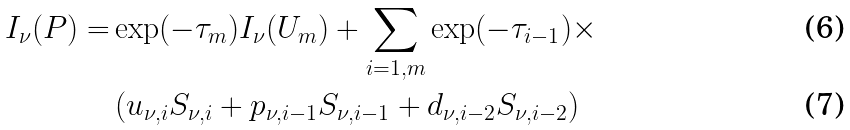<formula> <loc_0><loc_0><loc_500><loc_500>I _ { \nu } ( P ) = & \exp ( - \tau _ { m } ) I _ { \nu } ( U _ { m } ) + \sum _ { i = 1 , m } \exp ( - \tau _ { i - 1 } ) \times \\ & \left ( u _ { \nu , i } S _ { \nu , i } + p _ { \nu , i - 1 } S _ { \nu , i - 1 } + d _ { \nu , i - 2 } S _ { \nu , i - 2 } \right )</formula> 